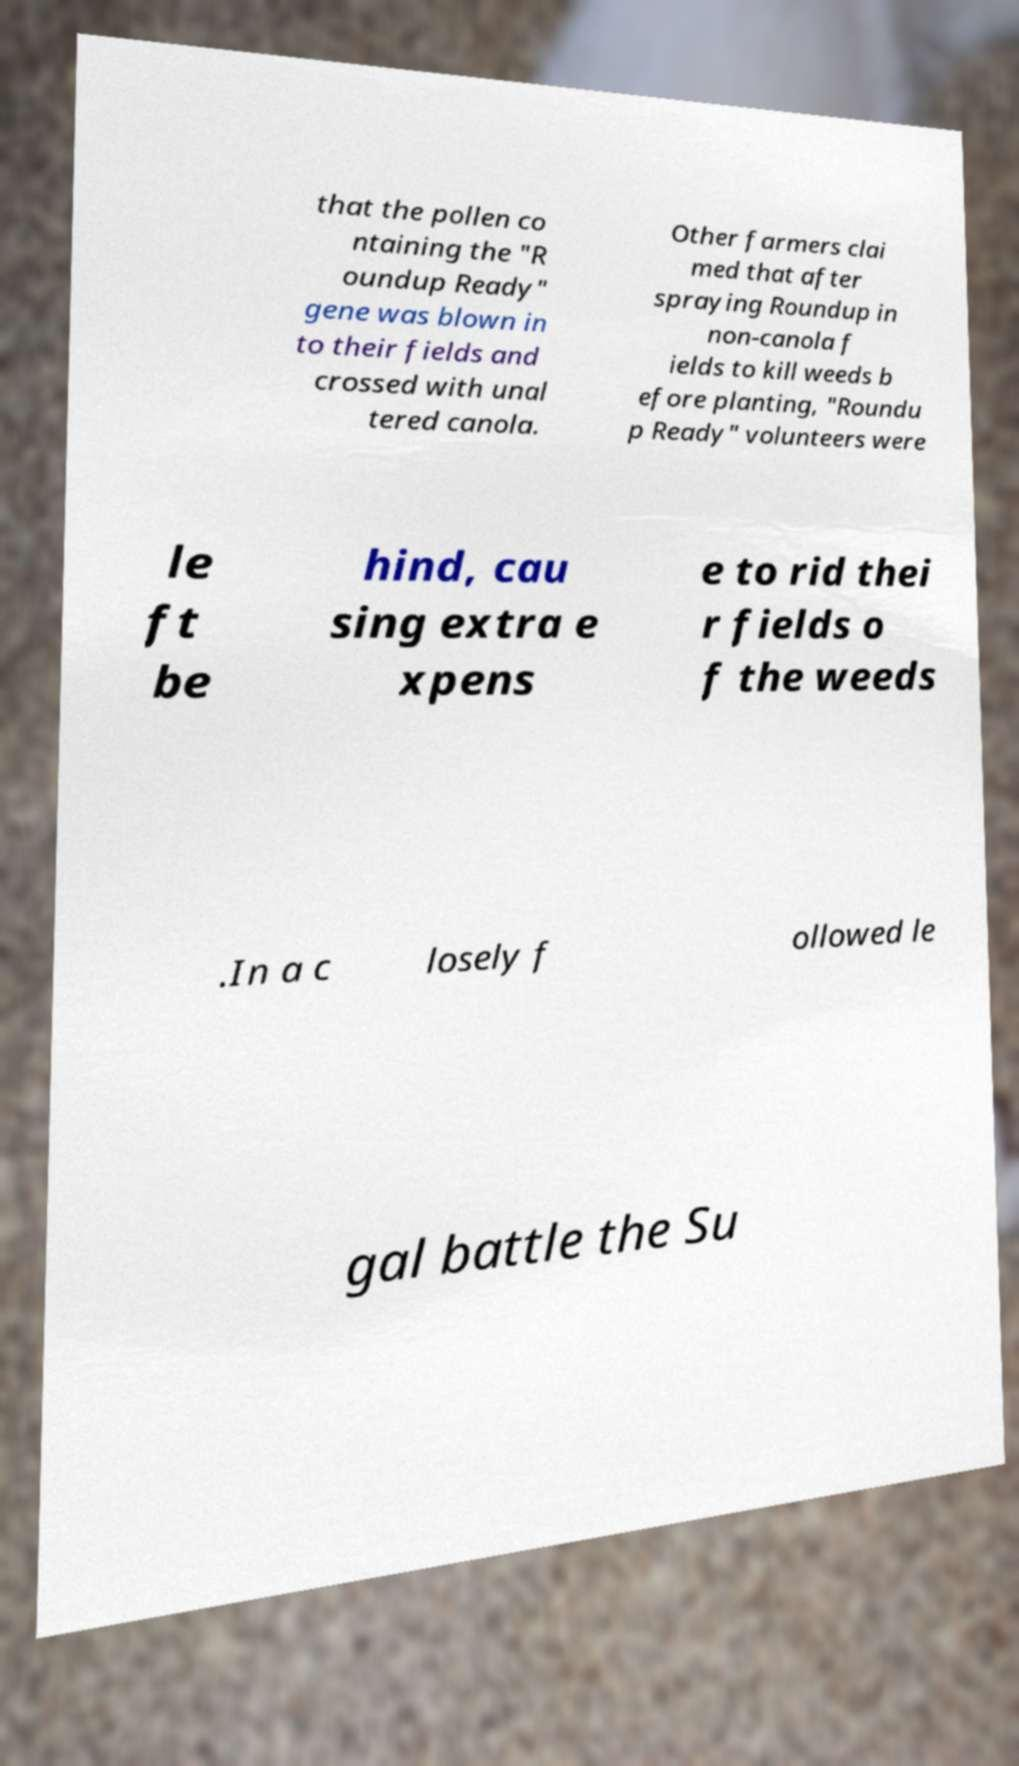I need the written content from this picture converted into text. Can you do that? that the pollen co ntaining the "R oundup Ready" gene was blown in to their fields and crossed with unal tered canola. Other farmers clai med that after spraying Roundup in non-canola f ields to kill weeds b efore planting, "Roundu p Ready" volunteers were le ft be hind, cau sing extra e xpens e to rid thei r fields o f the weeds .In a c losely f ollowed le gal battle the Su 